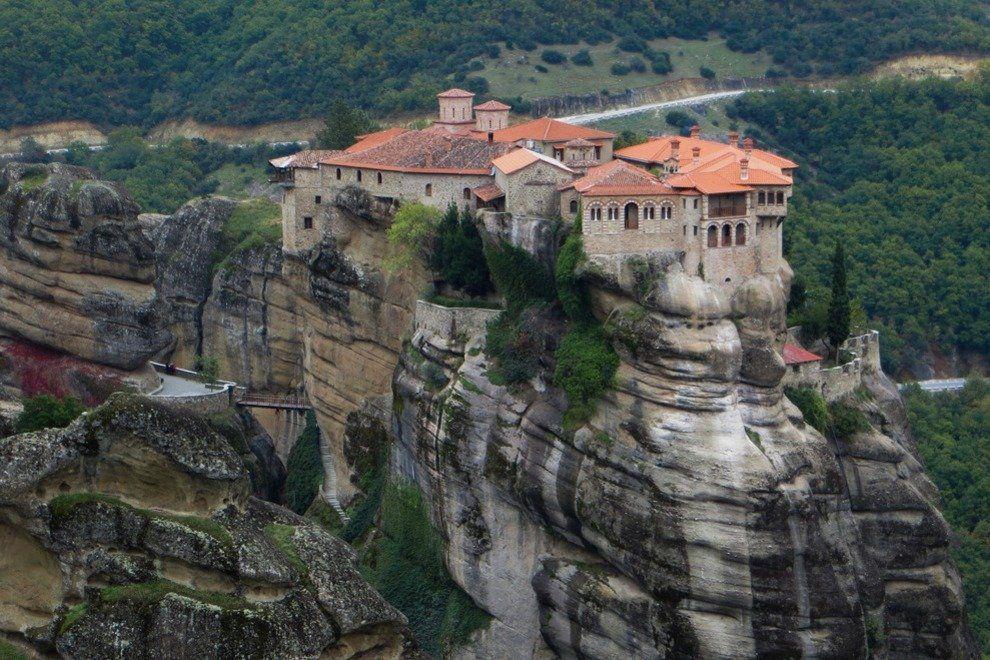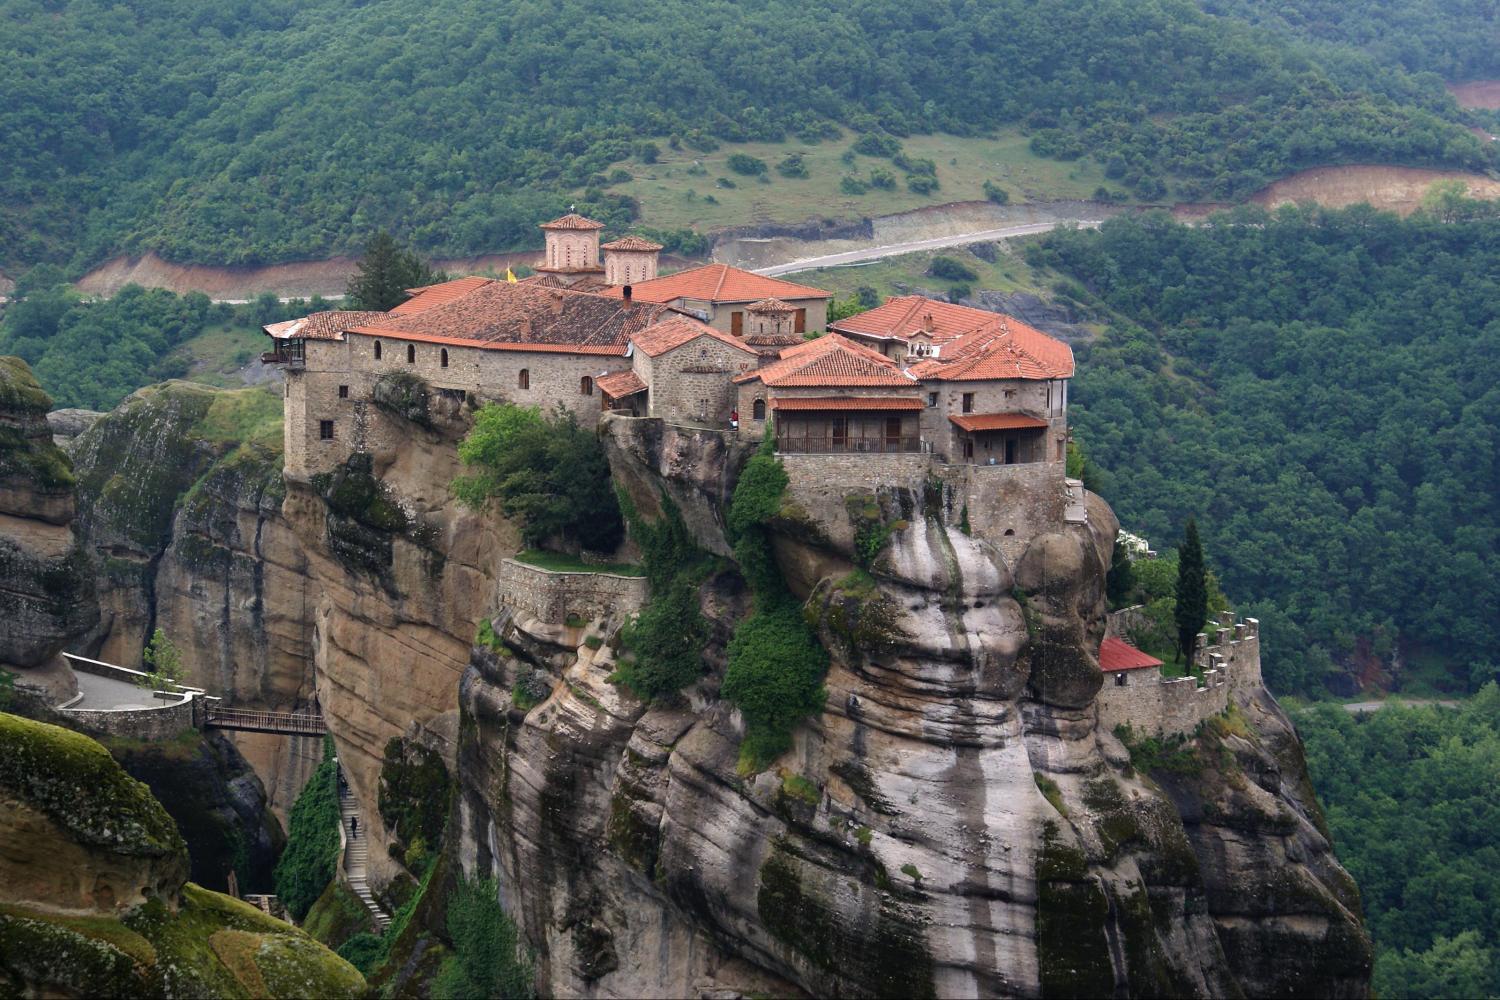The first image is the image on the left, the second image is the image on the right. Examine the images to the left and right. Is the description "Both images show a sky above the buildings on the cliffs." accurate? Answer yes or no. No. The first image is the image on the left, the second image is the image on the right. For the images shown, is this caption "These images feature a home on a cliff side from the same angle, and from a similar distance." true? Answer yes or no. Yes. 